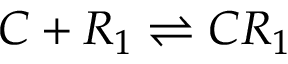Convert formula to latex. <formula><loc_0><loc_0><loc_500><loc_500>C + R _ { 1 } { \rightleftharpoons } C R _ { 1 }</formula> 